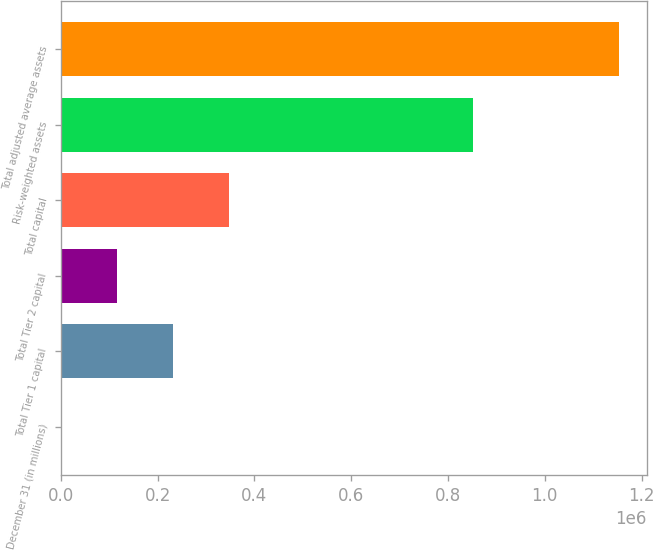<chart> <loc_0><loc_0><loc_500><loc_500><bar_chart><fcel>December 31 (in millions)<fcel>Total Tier 1 capital<fcel>Total Tier 2 capital<fcel>Total capital<fcel>Risk-weighted assets<fcel>Total adjusted average assets<nl><fcel>2005<fcel>232113<fcel>117059<fcel>347167<fcel>850643<fcel>1.15255e+06<nl></chart> 